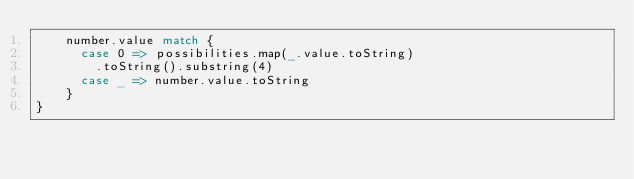<code> <loc_0><loc_0><loc_500><loc_500><_Scala_>    number.value match {
      case 0 => possibilities.map(_.value.toString)
        .toString().substring(4)
      case _ => number.value.toString
    }
}
</code> 